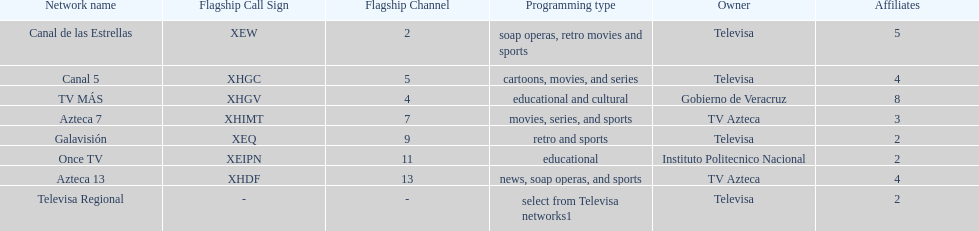How many networks have more affiliates than canal de las estrellas? 1. 